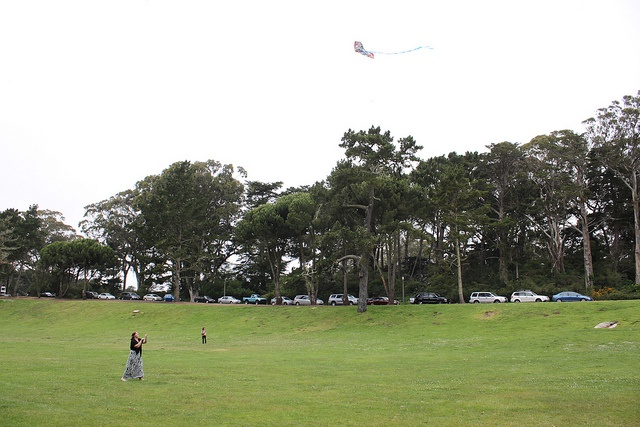Describe the objects in this image and their specific colors. I can see people in white, gray, darkgray, black, and olive tones, car in white, black, gray, darkgray, and lightgray tones, truck in white, black, darkgray, lightgray, and gray tones, car in white, black, gray, olive, and darkgray tones, and car in white, olive, gray, navy, and darkgray tones in this image. 